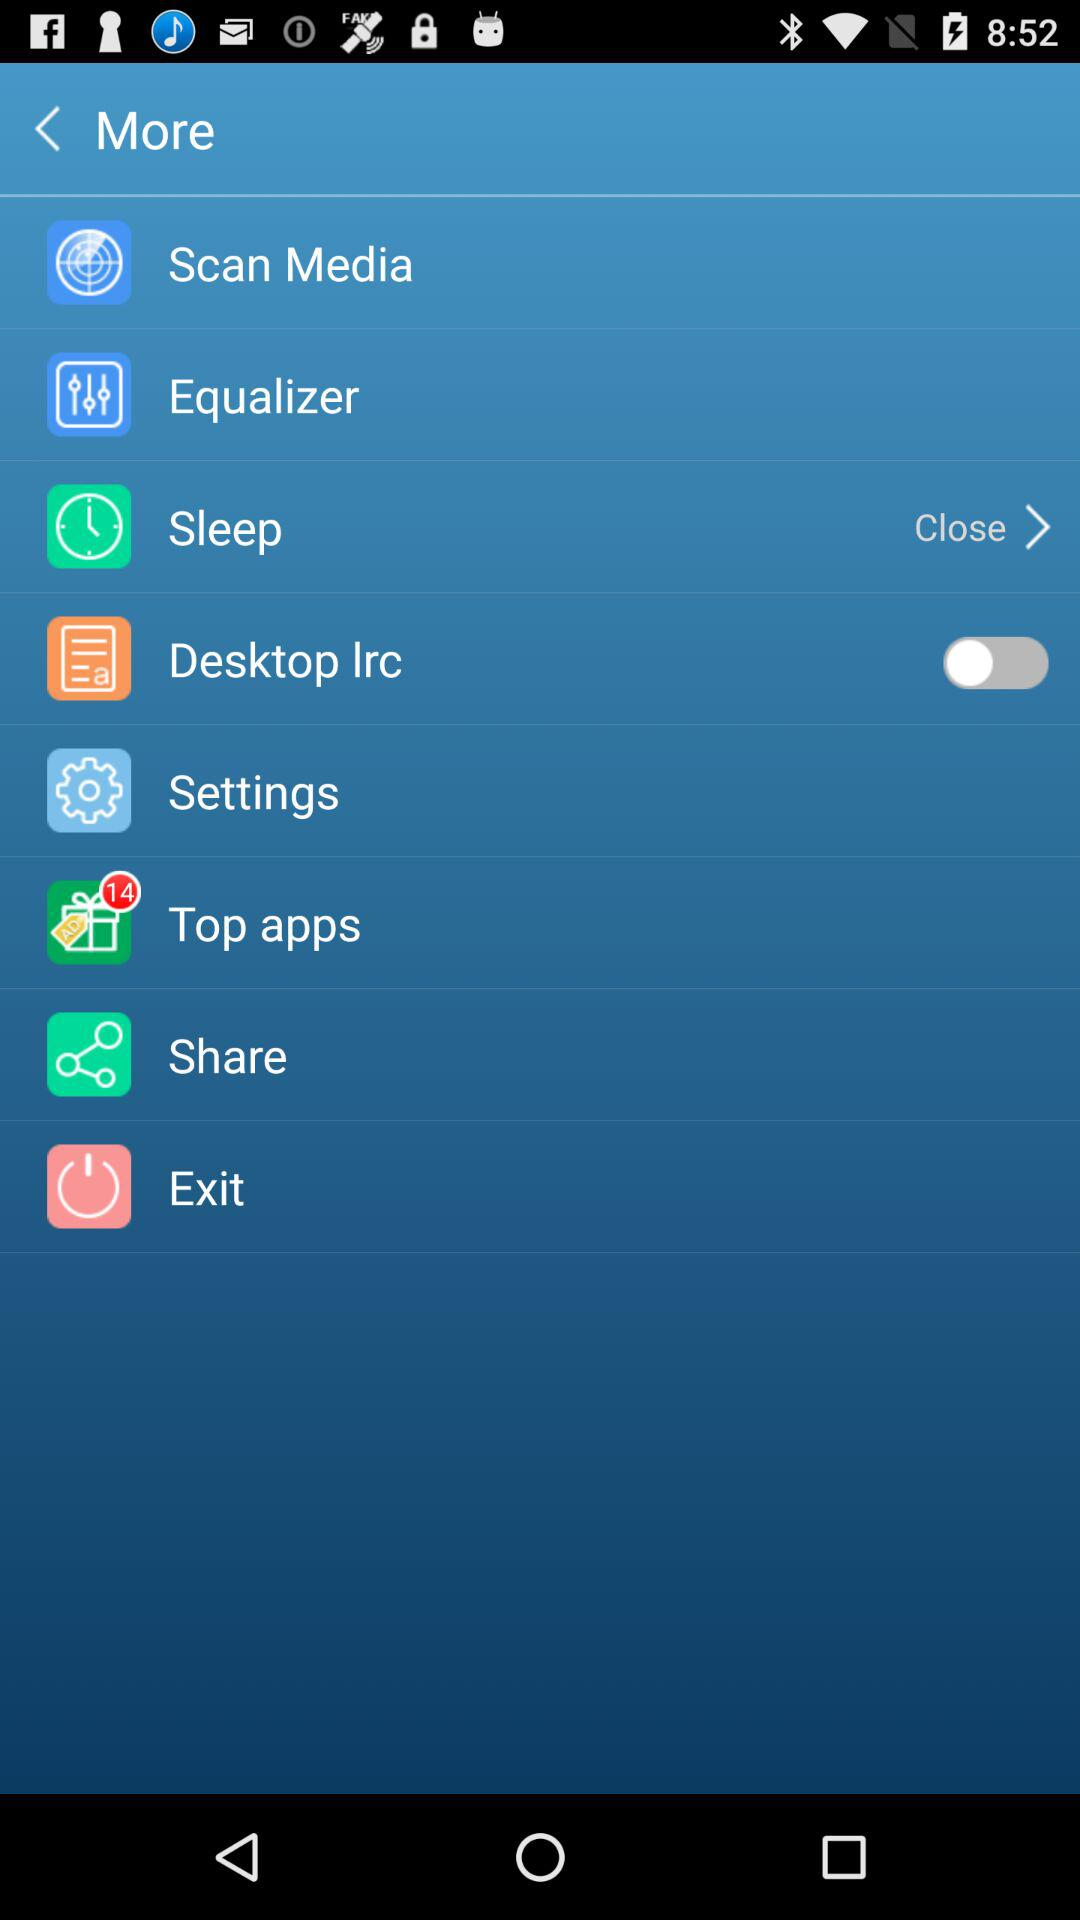What is the status of the "Desktop Irc"? The status is "off". 